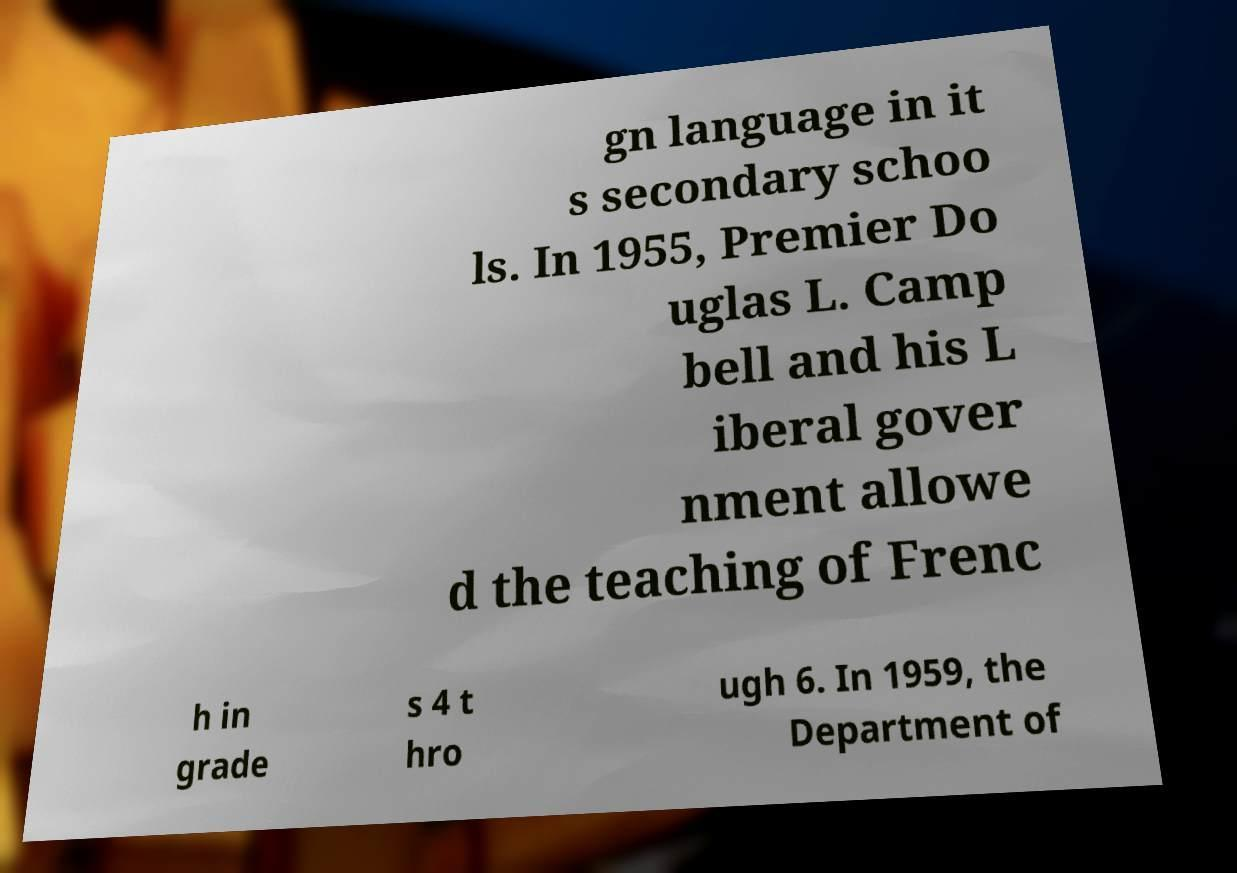Please identify and transcribe the text found in this image. gn language in it s secondary schoo ls. In 1955, Premier Do uglas L. Camp bell and his L iberal gover nment allowe d the teaching of Frenc h in grade s 4 t hro ugh 6. In 1959, the Department of 